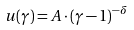Convert formula to latex. <formula><loc_0><loc_0><loc_500><loc_500>u ( \gamma ) = A \cdot ( \gamma - 1 ) ^ { - \delta }</formula> 